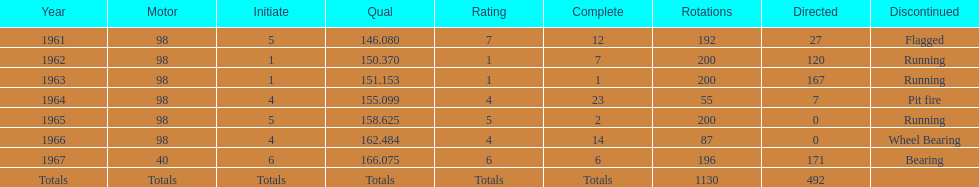Could you help me parse every detail presented in this table? {'header': ['Year', 'Motor', 'Initiate', 'Qual', 'Rating', 'Complete', 'Rotations', 'Directed', 'Discontinued'], 'rows': [['1961', '98', '5', '146.080', '7', '12', '192', '27', 'Flagged'], ['1962', '98', '1', '150.370', '1', '7', '200', '120', 'Running'], ['1963', '98', '1', '151.153', '1', '1', '200', '167', 'Running'], ['1964', '98', '4', '155.099', '4', '23', '55', '7', 'Pit fire'], ['1965', '98', '5', '158.625', '5', '2', '200', '0', 'Running'], ['1966', '98', '4', '162.484', '4', '14', '87', '0', 'Wheel Bearing'], ['1967', '40', '6', '166.075', '6', '6', '196', '171', 'Bearing'], ['Totals', 'Totals', 'Totals', 'Totals', 'Totals', 'Totals', '1130', '492', '']]} How many times did he finish in the top three? 2. 